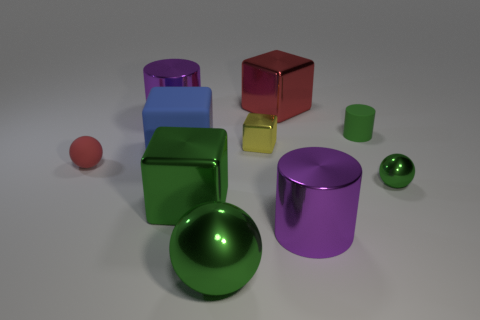What shape is the purple metallic thing on the right side of the cube that is behind the rubber cylinder?
Give a very brief answer. Cylinder. Is the number of large red metallic things behind the red block less than the number of cylinders right of the large green metal ball?
Ensure brevity in your answer.  Yes. What size is the yellow thing that is the same shape as the large blue thing?
Ensure brevity in your answer.  Small. Is there any other thing that is the same size as the blue cube?
Your answer should be very brief. Yes. How many things are either purple shiny cylinders that are in front of the small yellow thing or large metal cylinders right of the big rubber cube?
Your answer should be very brief. 1. Is the blue rubber object the same size as the rubber sphere?
Offer a very short reply. No. Is the number of small matte spheres greater than the number of big brown metallic balls?
Provide a succinct answer. Yes. What number of other objects are there of the same color as the tiny metallic block?
Your response must be concise. 0. How many things are purple cylinders or small cylinders?
Provide a short and direct response. 3. Do the purple metal thing to the left of the tiny block and the big rubber thing have the same shape?
Give a very brief answer. No. 